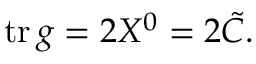Convert formula to latex. <formula><loc_0><loc_0><loc_500><loc_500>t r \, g = 2 X ^ { 0 } = 2 { \tilde { C } } .</formula> 